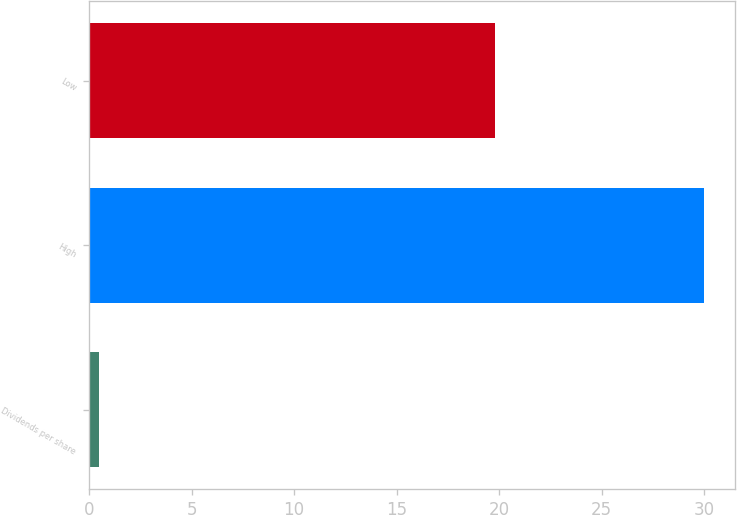<chart> <loc_0><loc_0><loc_500><loc_500><bar_chart><fcel>Dividends per share<fcel>High<fcel>Low<nl><fcel>0.49<fcel>30<fcel>19.8<nl></chart> 